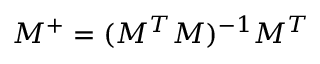Convert formula to latex. <formula><loc_0><loc_0><loc_500><loc_500>M ^ { + } = ( M ^ { T } M ) ^ { - 1 } M ^ { T }</formula> 